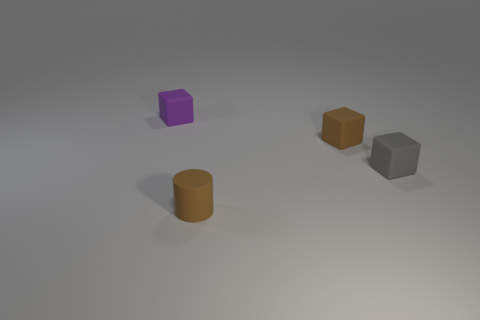What time of day does the lighting in the image suggest and what could be the source? The lighting in the image appears soft and diffused, lacking harsh shadows, which could suggest an indoor setting with artificial light. The light source seems to be coming from above, as indicated by the gentle shadows beneath the objects. 